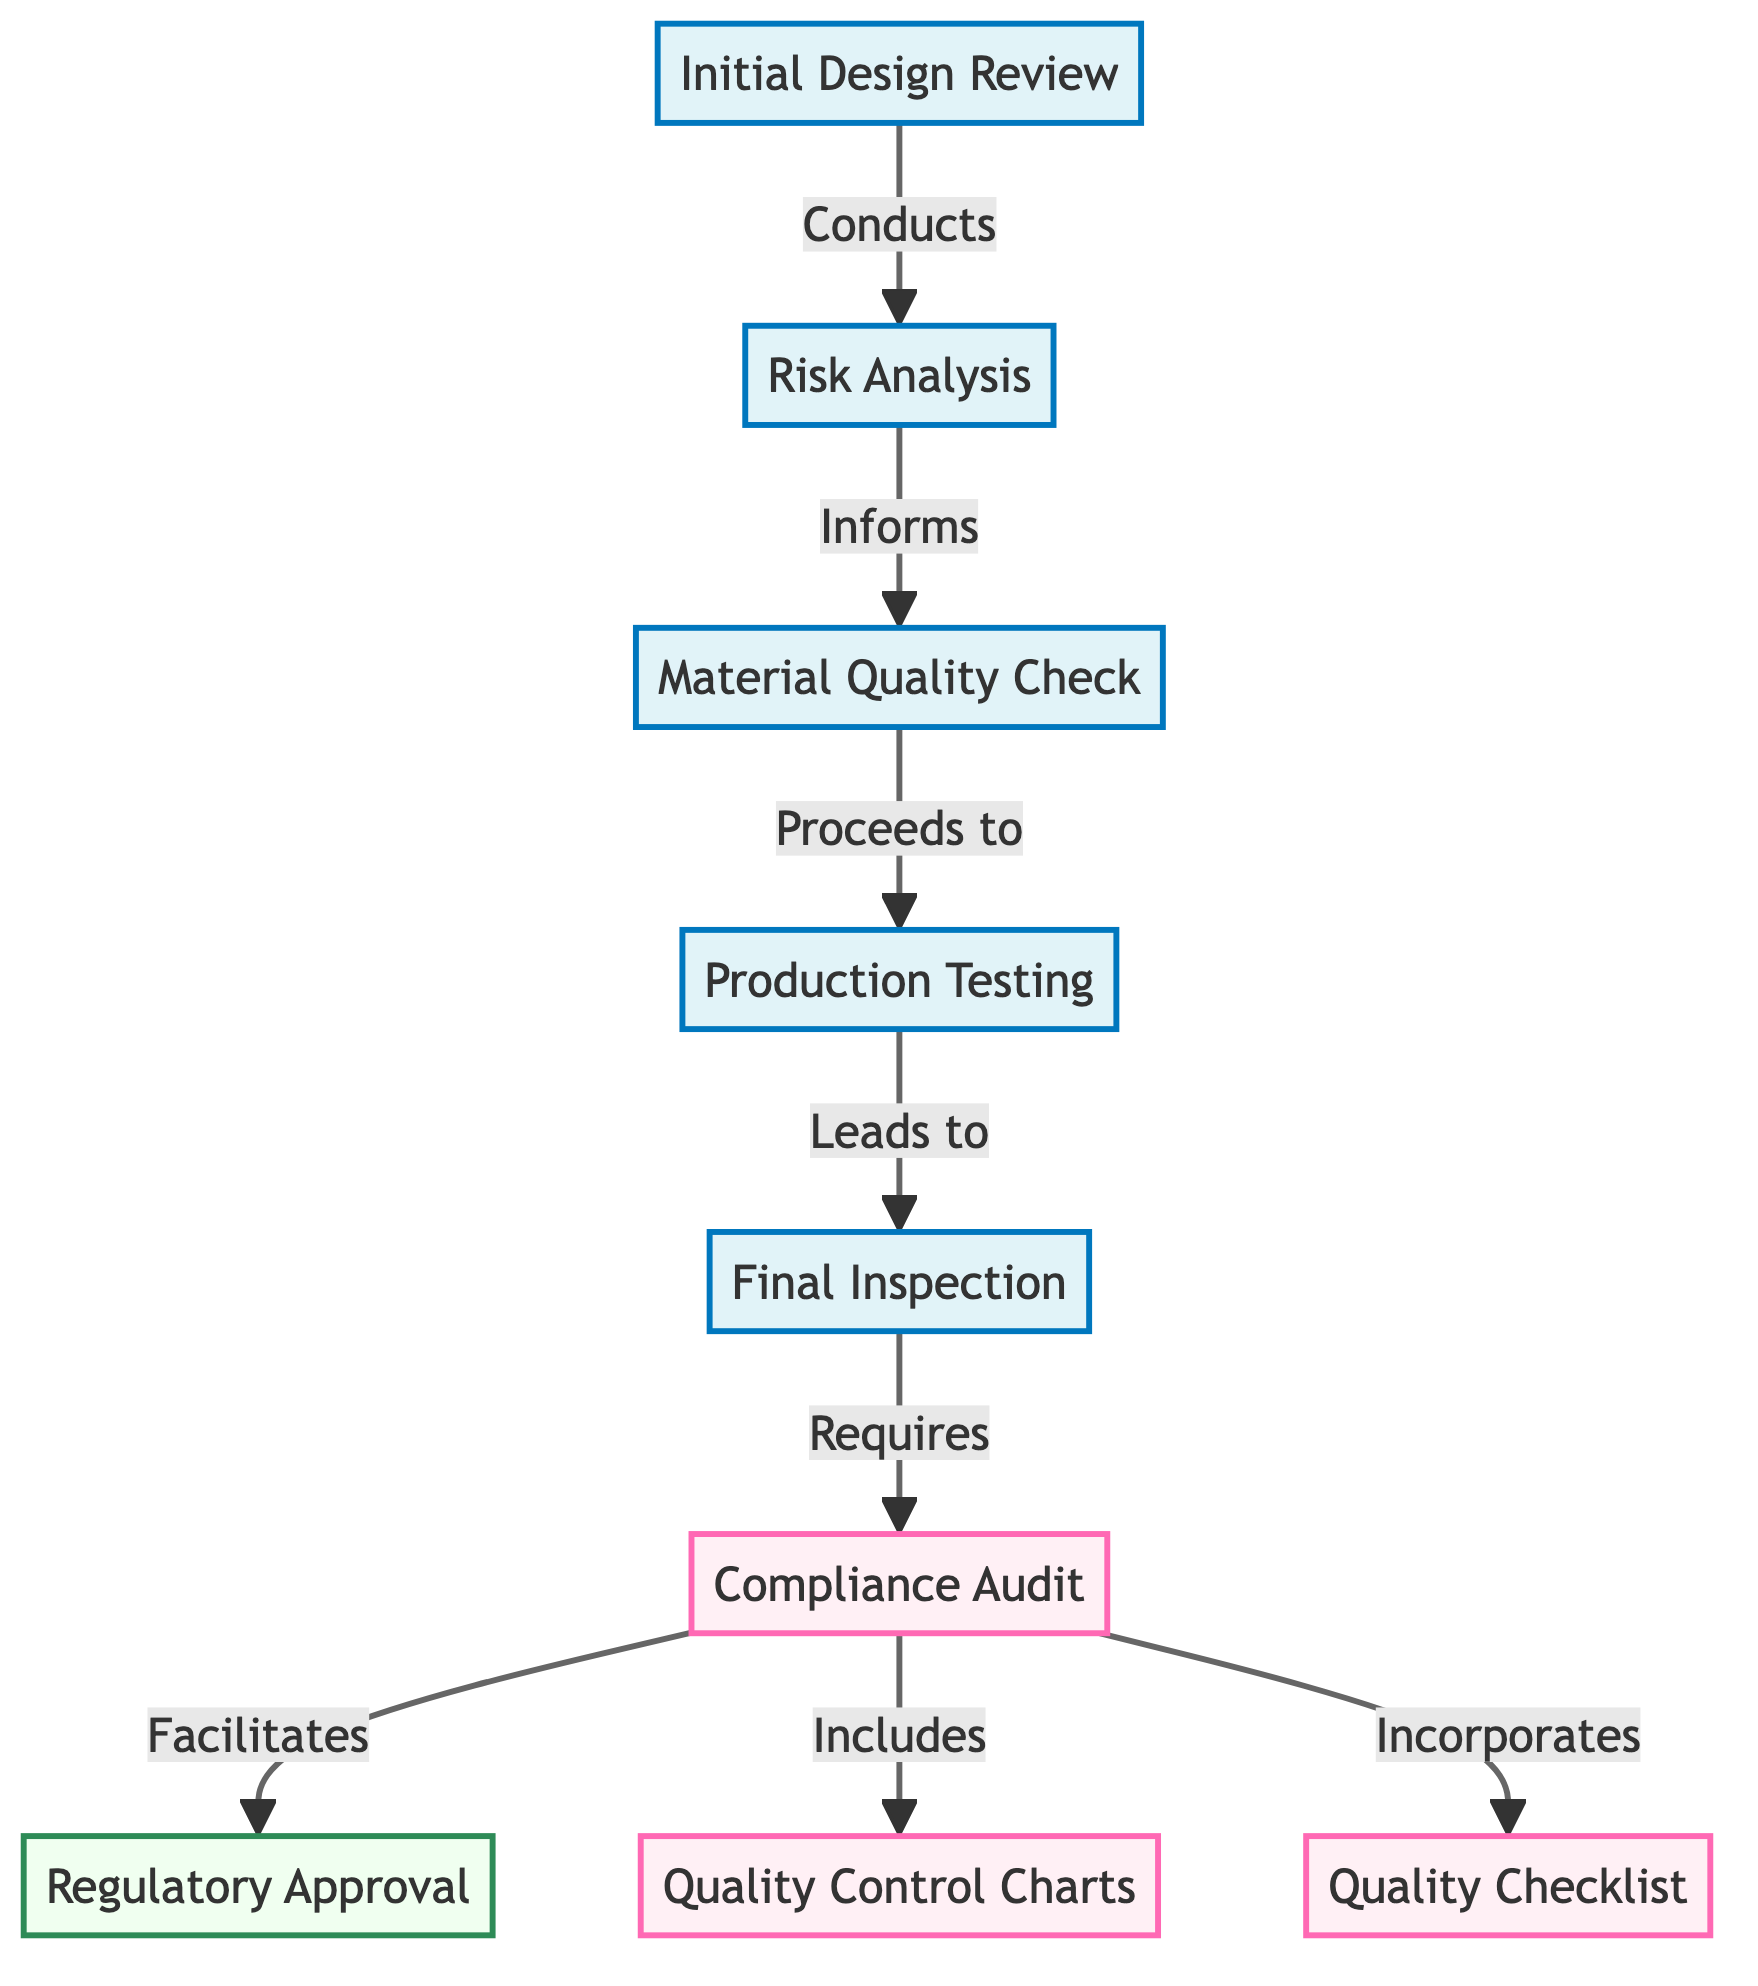What is the first step in the quality control process? The diagram indicates that the first step in the quality control process is the "Initial Design Review." It is the starting point before any further actions can be taken.
Answer: Initial Design Review How many audit-related steps are present in the diagram? The diagram includes three audit-related steps: "Compliance Audit," "Quality Control Charts," and "Quality Checklist." Each of these is indicated under audit-related operations.
Answer: 3 What process follows the 'Material Quality Check'? The flow of the diagram shows that after the "Material Quality Check," the next process is "Production Testing," indicating a sequential workflow in quality control.
Answer: Production Testing Which step incorporates both quality control charts and checklists? The "Compliance Audit" step incorporates both "Quality Control Charts" and "Quality Checklist" as indicated by the arrows pointing to these two elements.
Answer: Compliance Audit What step leads directly to regulatory approval? The diagram shows that the "Compliance Audit" leads directly to "Regulatory Approval," meaning the completion of the audit is essential before seeking approval from regulatory authorities.
Answer: Compliance Audit Which process requires the final inspection? According to the structure of the diagram, the "Final Inspection" is a requirement that must be met after "Production Testing," emphasizing the importance of thorough checking before the next steps.
Answer: Production Testing What is the last step in this quality control process? The final step in this series of processes as represented in the diagram is "Regulatory Approval," which indicates that once all previous checks are passed, this is the final hurdle to compliance.
Answer: Regulatory Approval Which process informs the material quality check? The "Risk Analysis" step informs the "Material Quality Check," showing a flow of information that helps determine the quality of materials used in production.
Answer: Risk Analysis What is the relationship between production testing and final inspection? The diagram indicates that "Production Testing" leads to "Final Inspection," which establishes a direct sequence where testing must be completed before any inspection can take place.
Answer: Production Testing 